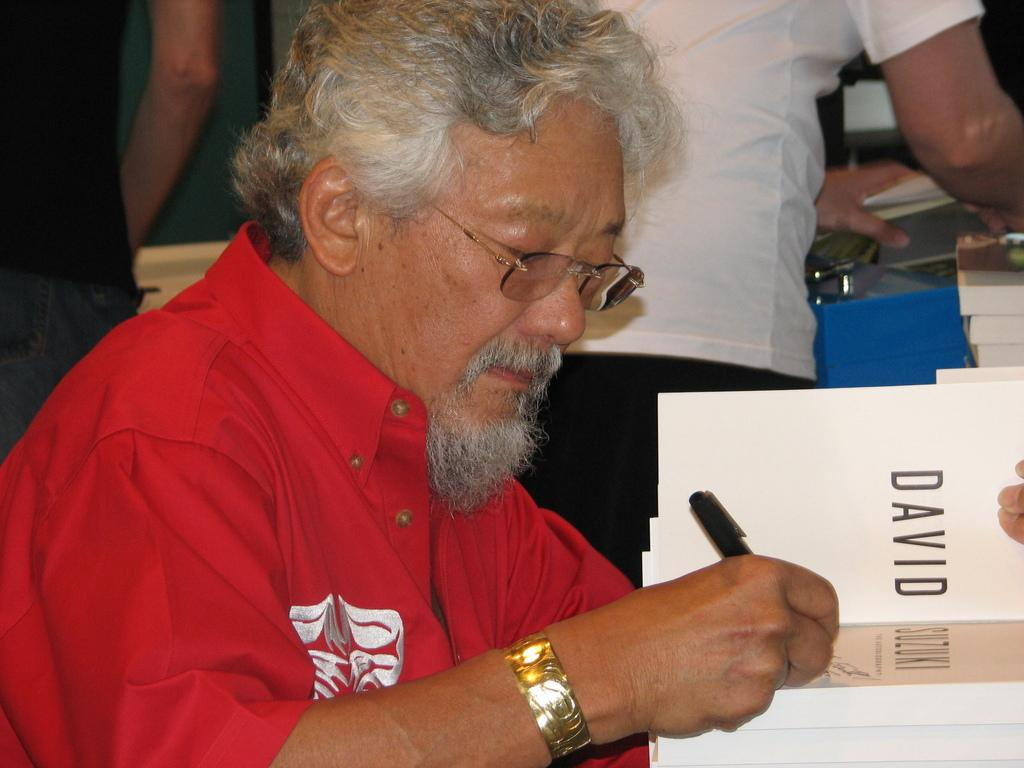Who is the main subject in the image? There is a man in the image. What is the man holding in his hands? The man is holding a book and a pen. What can be seen near the man in the image? There are people standing near a table. What is on the table in the image? The table contains books. Can you see a stamp on the agreement that the man is holding in the image? There is no agreement or stamp present in the image. 